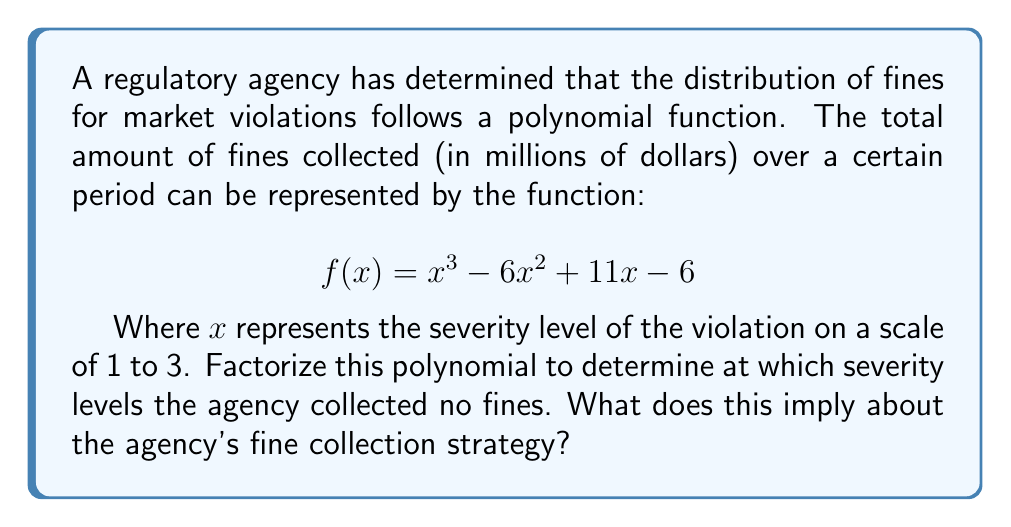Could you help me with this problem? To solve this problem, we need to factorize the given polynomial and find its roots. The roots will represent the severity levels at which no fines were collected.

Step 1: Factorize the polynomial $f(x) = x^3 - 6x^2 + 11x - 6$

We can use the factor theorem to guess one factor. Let's try $x = 1$:
$f(1) = 1^3 - 6(1)^2 + 11(1) - 6 = 1 - 6 + 11 - 6 = 0$

So, $(x - 1)$ is a factor. We can now use polynomial long division:

$x^3 - 6x^2 + 11x - 6 = (x - 1)(x^2 - 5x + 6)$

The quadratic factor $x^2 - 5x + 6$ can be further factored:

$x^2 - 5x + 6 = (x - 2)(x - 3)$

Therefore, the fully factored polynomial is:

$$f(x) = (x - 1)(x - 2)(x - 3)$$

Step 2: Identify the roots

The roots of the polynomial are the values of $x$ that make each factor equal to zero:
$x = 1, x = 2, x = 3$

Step 3: Interpret the results

The agency collected no fines at severity levels 1, 2, and 3. This implies that the agency's fine collection strategy is potentially flawed, as it suggests no fines were collected at any severity level within the given scale. This could indicate:

1. The scale might not be appropriately defined for the violations encountered.
2. There might be issues with the fine collection process or data recording.
3. The polynomial model might not accurately represent the actual fine distribution and may need refinement.

The regulatory agency director should investigate these possibilities to improve the effectiveness of the fine collection system and ensure proper enforcement of market regulations.
Answer: Roots: $x = 1, 2, 3$; Implies flawed fine collection strategy 